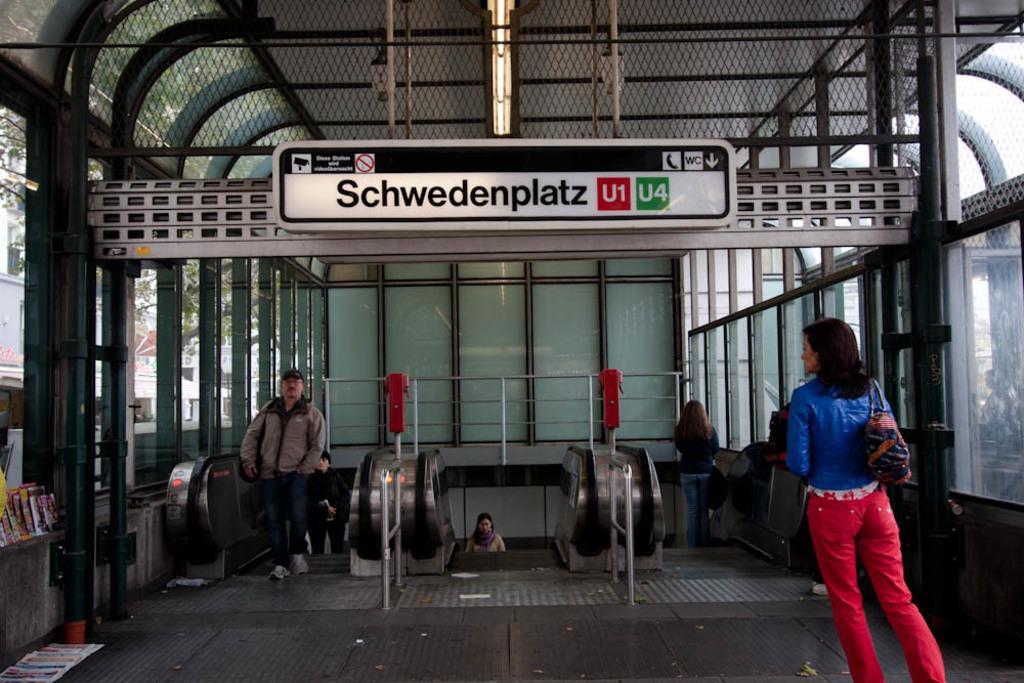Describe this image in one or two sentences. In this image we can see a woman. She is wearing blue jacket, red pant and carrying bag. Background of the image we can see people on the escalators. Railing is there. At the top of the image, lights are attached to the roof and one board is present with some text written on it. To the both sides of the image, glass windows are there. In the left bottom of the image, we can see some books and newspapers. 